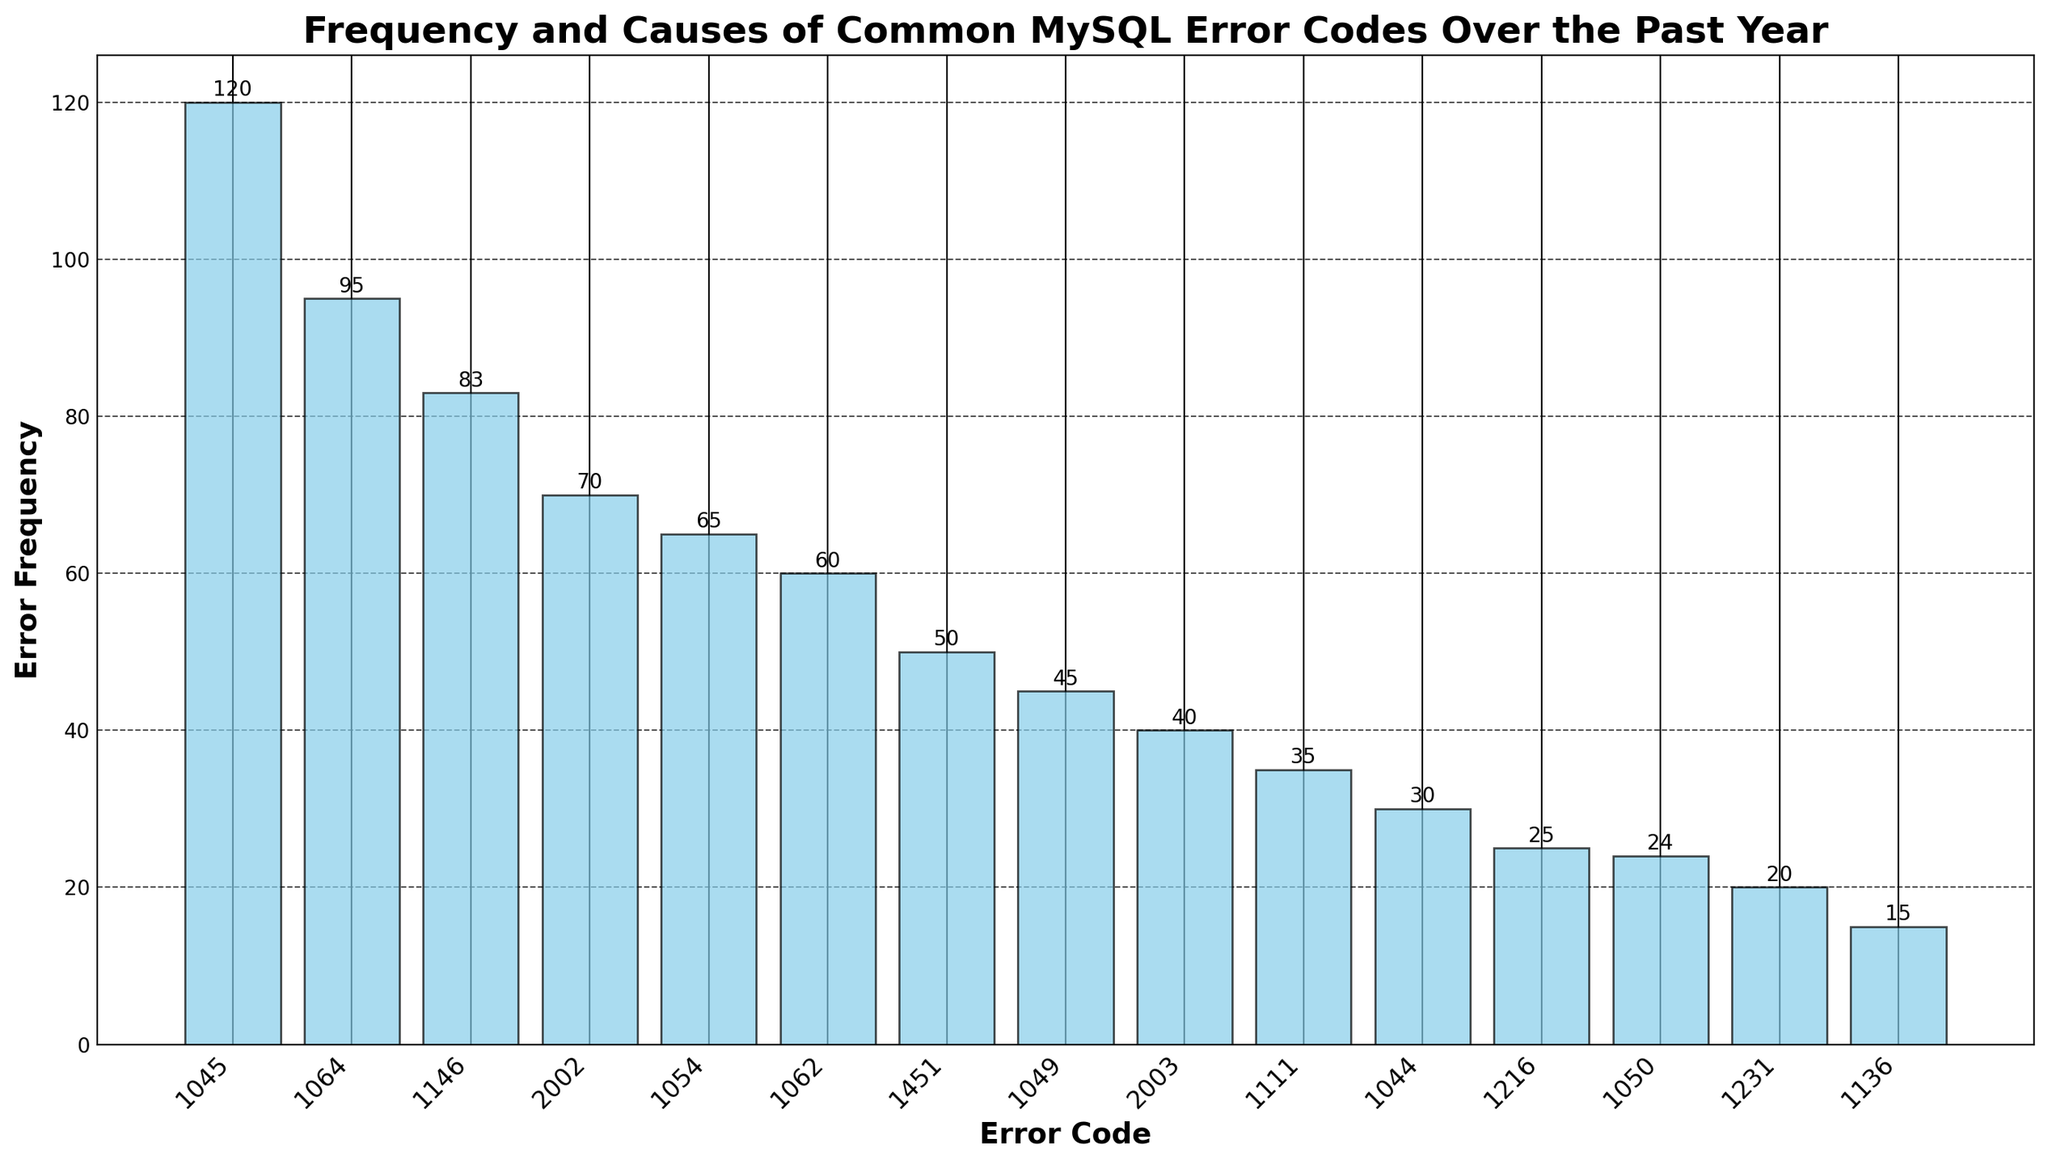What's the most common MySQL error code over the past year? The figure shows various MySQL error codes and their frequencies. The tallest bar represents the most frequent error.
Answer: 1045 Which error code has a higher frequency, 1062 or 1054? By visually comparing the heights of the bars labeled 1062 and 1054, the bar for 1062 is slightly shorter than the bar for 1054.
Answer: 1054 What is the total number of errors caused by "Access denied for user" for both error codes combined? The error codes 1045 and 1044 both have the cause "Access denied for user." Summing their frequencies: 120 + 30 = 150.
Answer: 150 What is the average frequency of error codes 2003, 1111, and 1136? To find the average, add the frequencies of error codes 2003 (40), 1111 (35), and 1136 (15), then divide by 3. (40 + 35 + 15) / 3 = 90 / 3 = 30.
Answer: 30 Which error code has the least occurrence, and what is its frequency? The shortest bar in the figure corresponds to the error code with the least frequency.
Answer: 1136, 15 How many more occurrences does error code 1064 have compared to error code 1054? Finding the difference in frequencies between 1064 and 1054: 95 - 65 = 30.
Answer: 30 Are there more errors related to foreign key constraints (error codes 1451 and 1216) or more errors related to database connectivity (error codes 2002 and 2003)? The total frequency for foreign key constraints (1451 and 1216) is 50 + 25 = 75, while for database connectivity (2002 and 2003) it is 70 + 40 = 110. Comparing these sums, database connectivity related errors have a higher frequency.
Answer: Database connectivity Identify the error code(s) for which the frequency is less than 30. Frequencies less than 30 are represented by shorter bars below the 30 mark. The error codes are 1216, 1050, 1231, and 1136.
Answer: 1216, 1050, 1231, 1136 